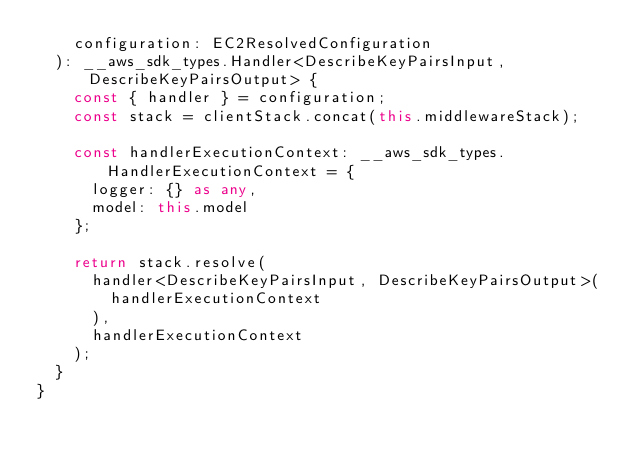<code> <loc_0><loc_0><loc_500><loc_500><_TypeScript_>    configuration: EC2ResolvedConfiguration
  ): __aws_sdk_types.Handler<DescribeKeyPairsInput, DescribeKeyPairsOutput> {
    const { handler } = configuration;
    const stack = clientStack.concat(this.middlewareStack);

    const handlerExecutionContext: __aws_sdk_types.HandlerExecutionContext = {
      logger: {} as any,
      model: this.model
    };

    return stack.resolve(
      handler<DescribeKeyPairsInput, DescribeKeyPairsOutput>(
        handlerExecutionContext
      ),
      handlerExecutionContext
    );
  }
}
</code> 